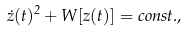<formula> <loc_0><loc_0><loc_500><loc_500>\dot { z } ( t ) ^ { 2 } + W [ z ( t ) ] = c o n s t . ,</formula> 